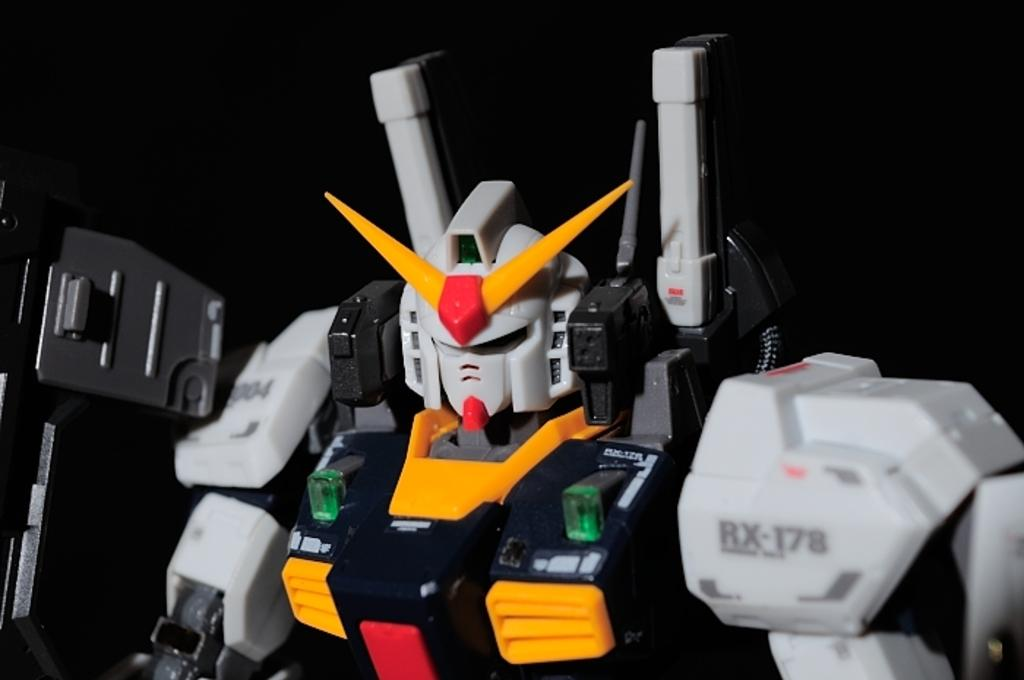What object can be seen in the image? There is a toy in the image. What can be observed about the lighting in the image? The background of the image is dark. What decision was made in the alley during the war in the image? There is no alley, war, or decision present in the image; it only features a toy with a dark background. 